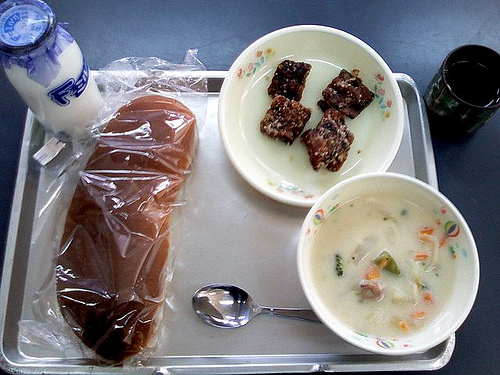<image>
Is there a plate under the food? Yes. The plate is positioned underneath the food, with the food above it in the vertical space. Where is the spoon in relation to the bowl? Is it under the bowl? Yes. The spoon is positioned underneath the bowl, with the bowl above it in the vertical space. 